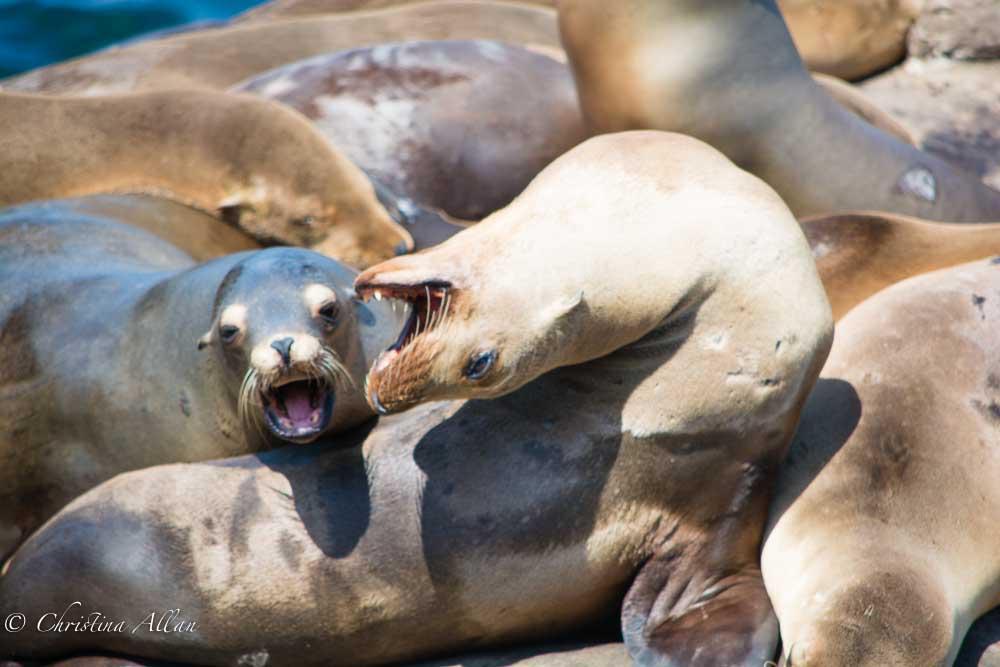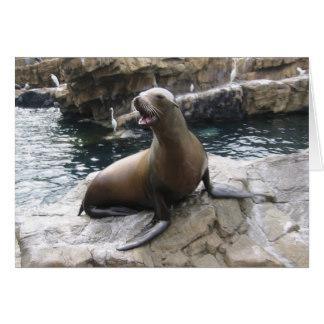The first image is the image on the left, the second image is the image on the right. Given the left and right images, does the statement "An image includes a seal in the foreground with its mouth open and head upside-down." hold true? Answer yes or no. Yes. The first image is the image on the left, the second image is the image on the right. Assess this claim about the two images: "There are more seals in the image on the right.". Correct or not? Answer yes or no. No. 